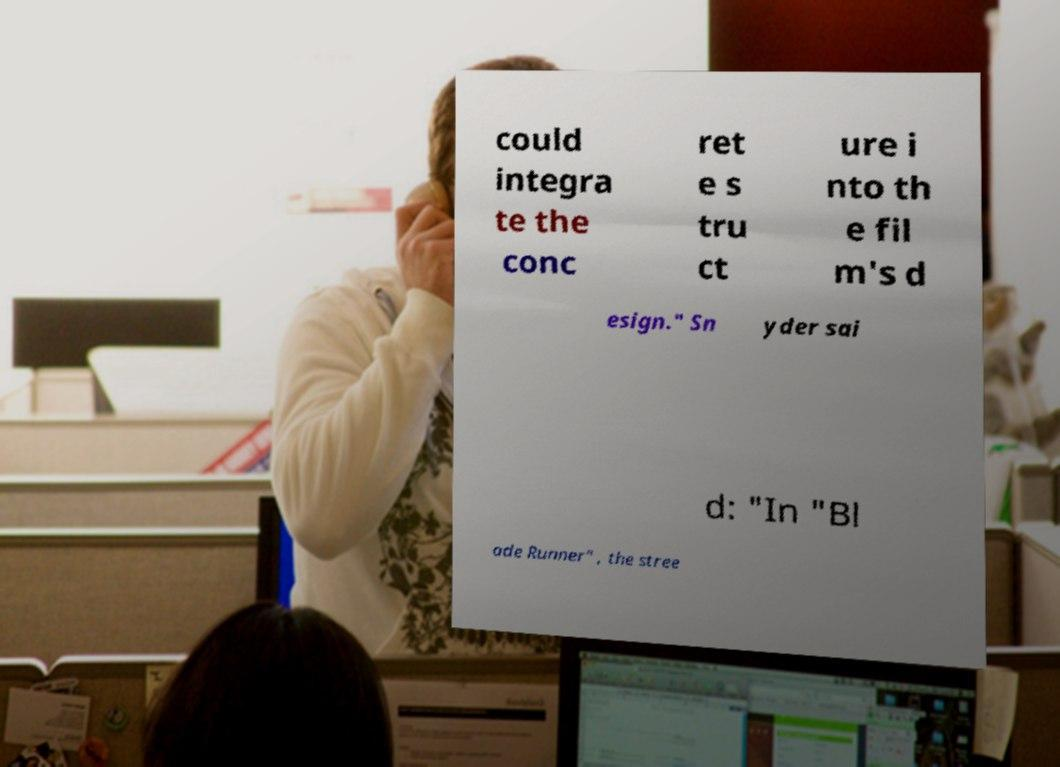Can you accurately transcribe the text from the provided image for me? could integra te the conc ret e s tru ct ure i nto th e fil m's d esign." Sn yder sai d: "In "Bl ade Runner" , the stree 